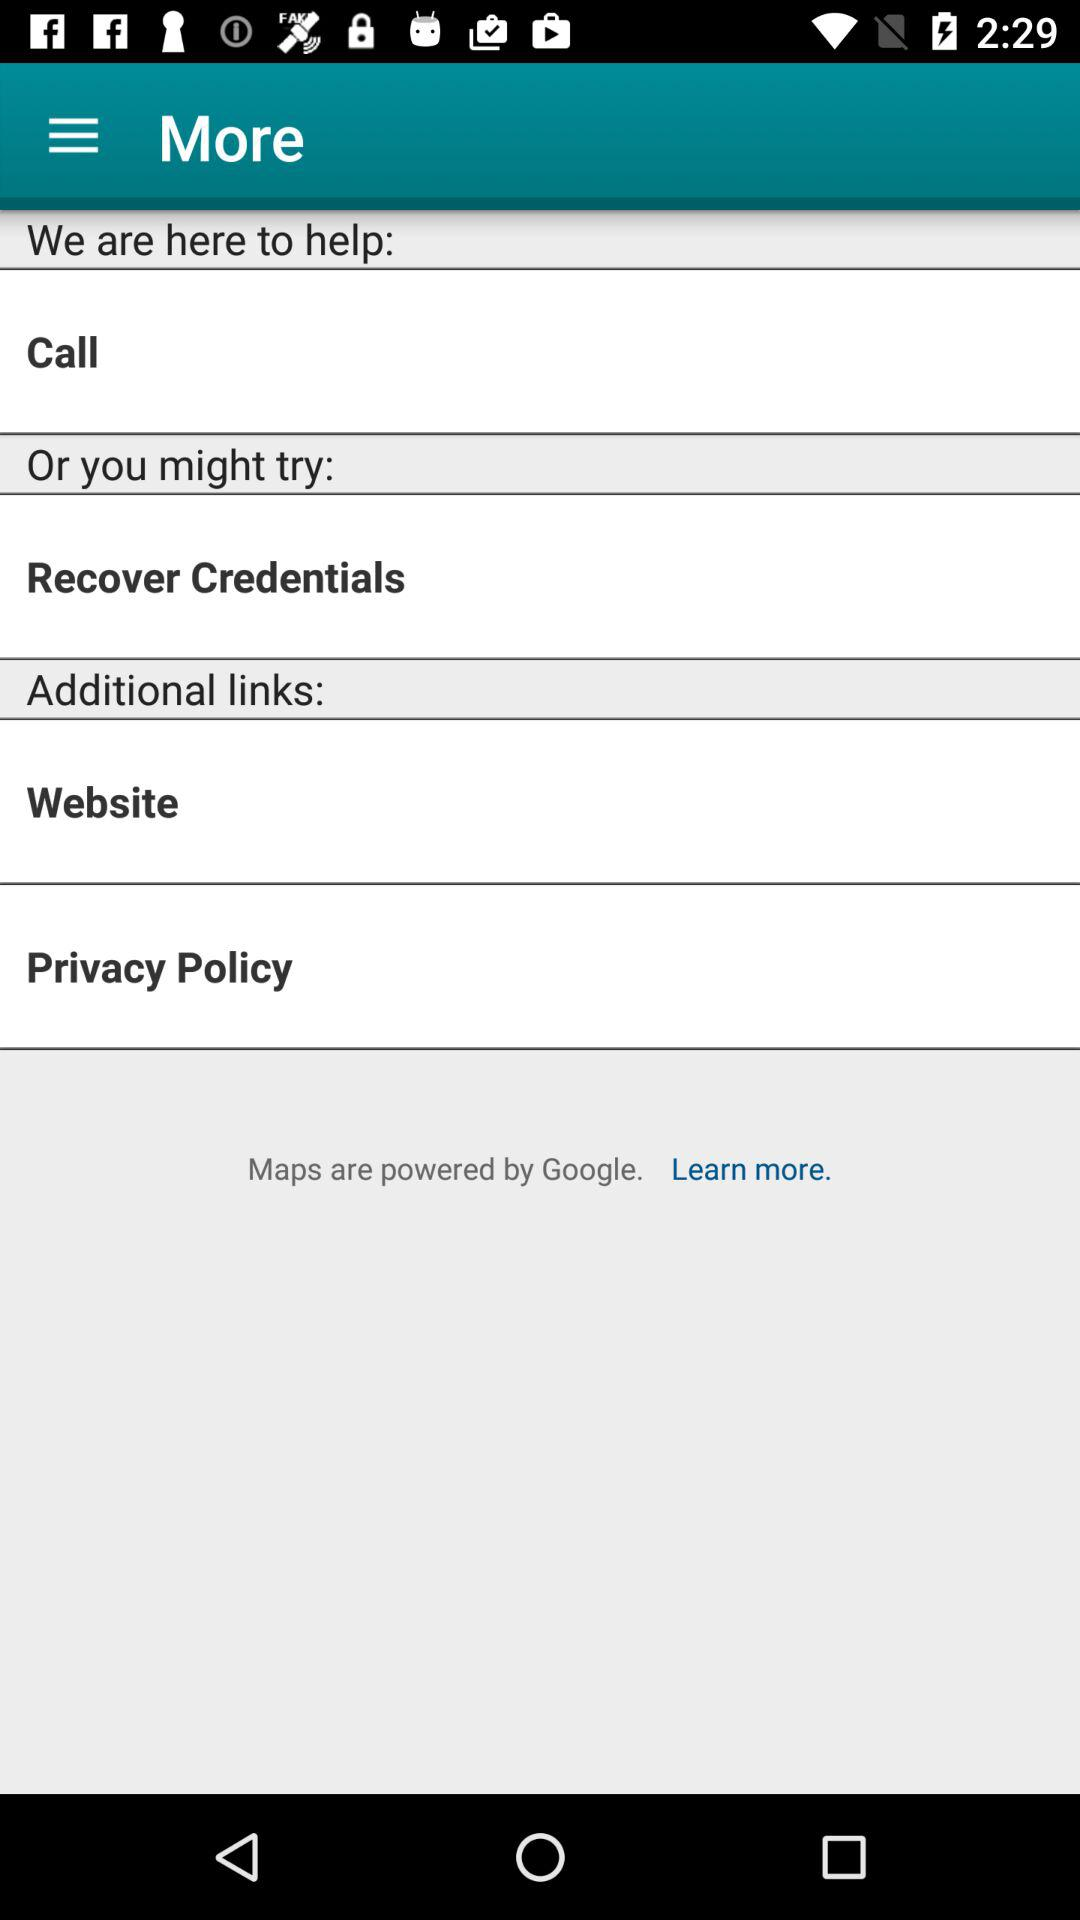What are the options in "Additional links"? The options in "Additional links" are "Website" and "Privacy Policy". 